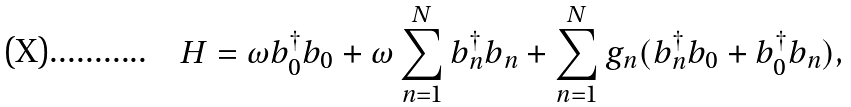Convert formula to latex. <formula><loc_0><loc_0><loc_500><loc_500>H = \omega b _ { 0 } ^ { \dagger } b _ { 0 } + \omega \sum _ { n = 1 } ^ { N } b _ { n } ^ { \dagger } b _ { n } + \sum _ { n = 1 } ^ { N } g _ { n } ( b _ { n } ^ { \dagger } b _ { 0 } + b _ { 0 } ^ { \dagger } b _ { n } ) ,</formula> 